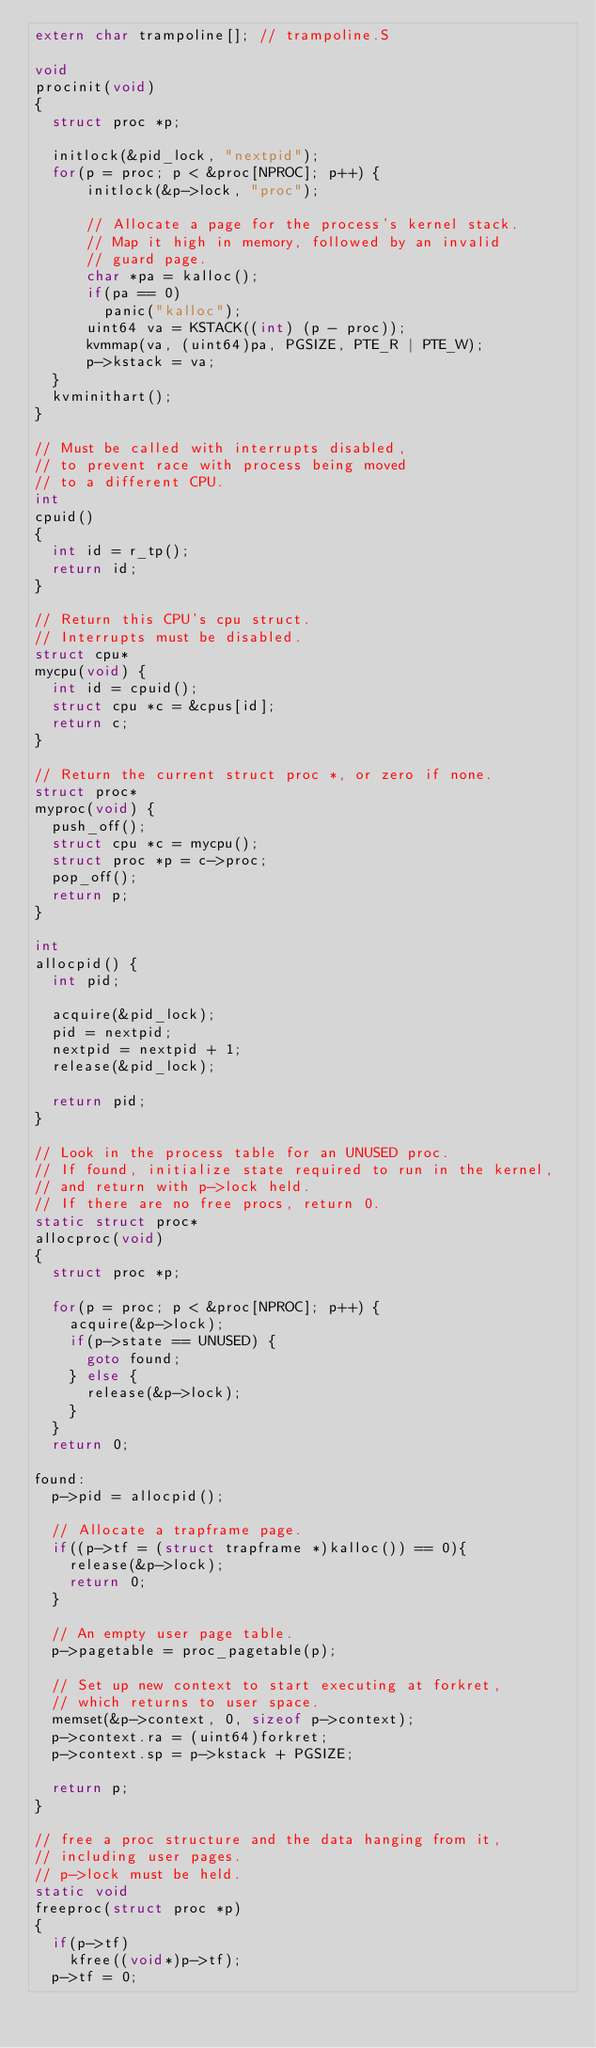<code> <loc_0><loc_0><loc_500><loc_500><_C_>extern char trampoline[]; // trampoline.S

void
procinit(void)
{
  struct proc *p;
  
  initlock(&pid_lock, "nextpid");
  for(p = proc; p < &proc[NPROC]; p++) {
      initlock(&p->lock, "proc");

      // Allocate a page for the process's kernel stack.
      // Map it high in memory, followed by an invalid
      // guard page.
      char *pa = kalloc();
      if(pa == 0)
        panic("kalloc");
      uint64 va = KSTACK((int) (p - proc));
      kvmmap(va, (uint64)pa, PGSIZE, PTE_R | PTE_W);
      p->kstack = va;
  }
  kvminithart();
}

// Must be called with interrupts disabled,
// to prevent race with process being moved
// to a different CPU.
int
cpuid()
{
  int id = r_tp();
  return id;
}

// Return this CPU's cpu struct.
// Interrupts must be disabled.
struct cpu*
mycpu(void) {
  int id = cpuid();
  struct cpu *c = &cpus[id];
  return c;
}

// Return the current struct proc *, or zero if none.
struct proc*
myproc(void) {
  push_off();
  struct cpu *c = mycpu();
  struct proc *p = c->proc;
  pop_off();
  return p;
}

int
allocpid() {
  int pid;
  
  acquire(&pid_lock);
  pid = nextpid;
  nextpid = nextpid + 1;
  release(&pid_lock);

  return pid;
}

// Look in the process table for an UNUSED proc.
// If found, initialize state required to run in the kernel,
// and return with p->lock held.
// If there are no free procs, return 0.
static struct proc*
allocproc(void)
{
  struct proc *p;

  for(p = proc; p < &proc[NPROC]; p++) {
    acquire(&p->lock);
    if(p->state == UNUSED) {
      goto found;
    } else {
      release(&p->lock);
    }
  }
  return 0;

found:
  p->pid = allocpid();

  // Allocate a trapframe page.
  if((p->tf = (struct trapframe *)kalloc()) == 0){
    release(&p->lock);
    return 0;
  }

  // An empty user page table.
  p->pagetable = proc_pagetable(p);

  // Set up new context to start executing at forkret,
  // which returns to user space.
  memset(&p->context, 0, sizeof p->context);
  p->context.ra = (uint64)forkret;
  p->context.sp = p->kstack + PGSIZE;

  return p;
}

// free a proc structure and the data hanging from it,
// including user pages.
// p->lock must be held.
static void
freeproc(struct proc *p)
{
  if(p->tf)
    kfree((void*)p->tf);
  p->tf = 0;</code> 